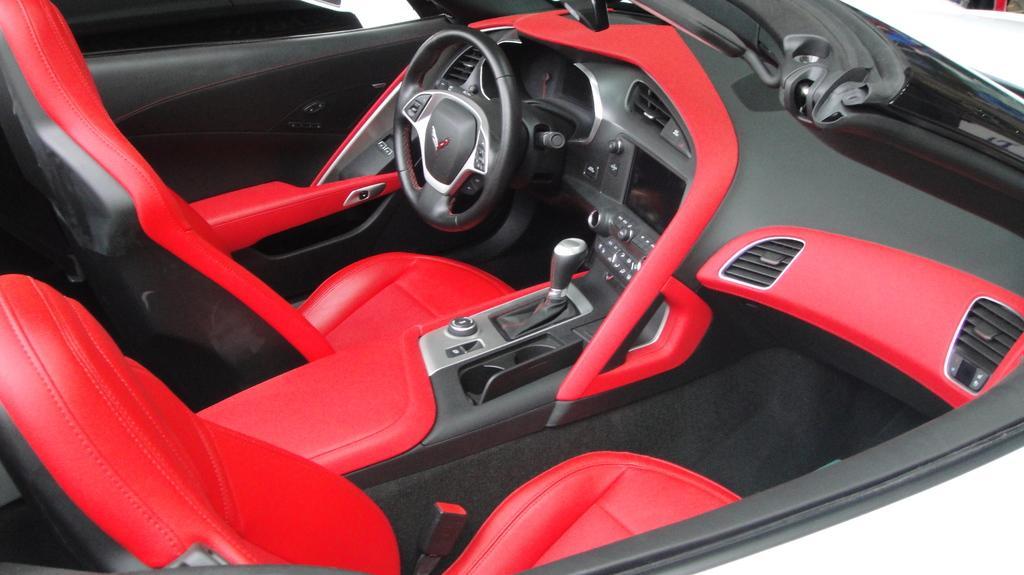How would you summarize this image in a sentence or two? In this picture we can see inside view of the car. In the front we can see steering, gear lever, LCD screen and buttons. On the right side, we can see two air conditioner vents. Behind we can see the red and black leather seats.  